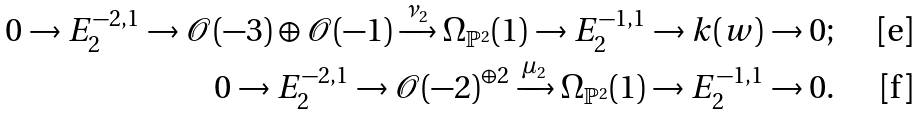<formula> <loc_0><loc_0><loc_500><loc_500>0 \to E _ { 2 } ^ { - 2 , 1 } \to \mathcal { O } ( - 3 ) \oplus \mathcal { O } ( - 1 ) \xrightarrow { \nu _ { 2 } } \Omega _ { \mathbb { P } ^ { 2 } } ( 1 ) \to E _ { 2 } ^ { - 1 , 1 } \to k ( w ) \to 0 ; \\ 0 \to E _ { 2 } ^ { - 2 , 1 } \to \mathcal { O } ( - 2 ) ^ { \oplus 2 } \xrightarrow { \mu _ { 2 } } \Omega _ { \mathbb { P } ^ { 2 } } ( 1 ) \to E _ { 2 } ^ { - 1 , 1 } \to 0 .</formula> 